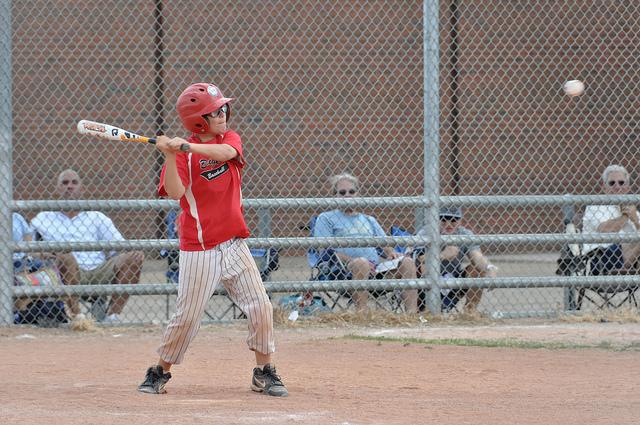Is this an adult's game?
Quick response, please. No. What color is the kid's shirt?
Quick response, please. Red. What are the fans sitting in?
Short answer required. Chairs. 